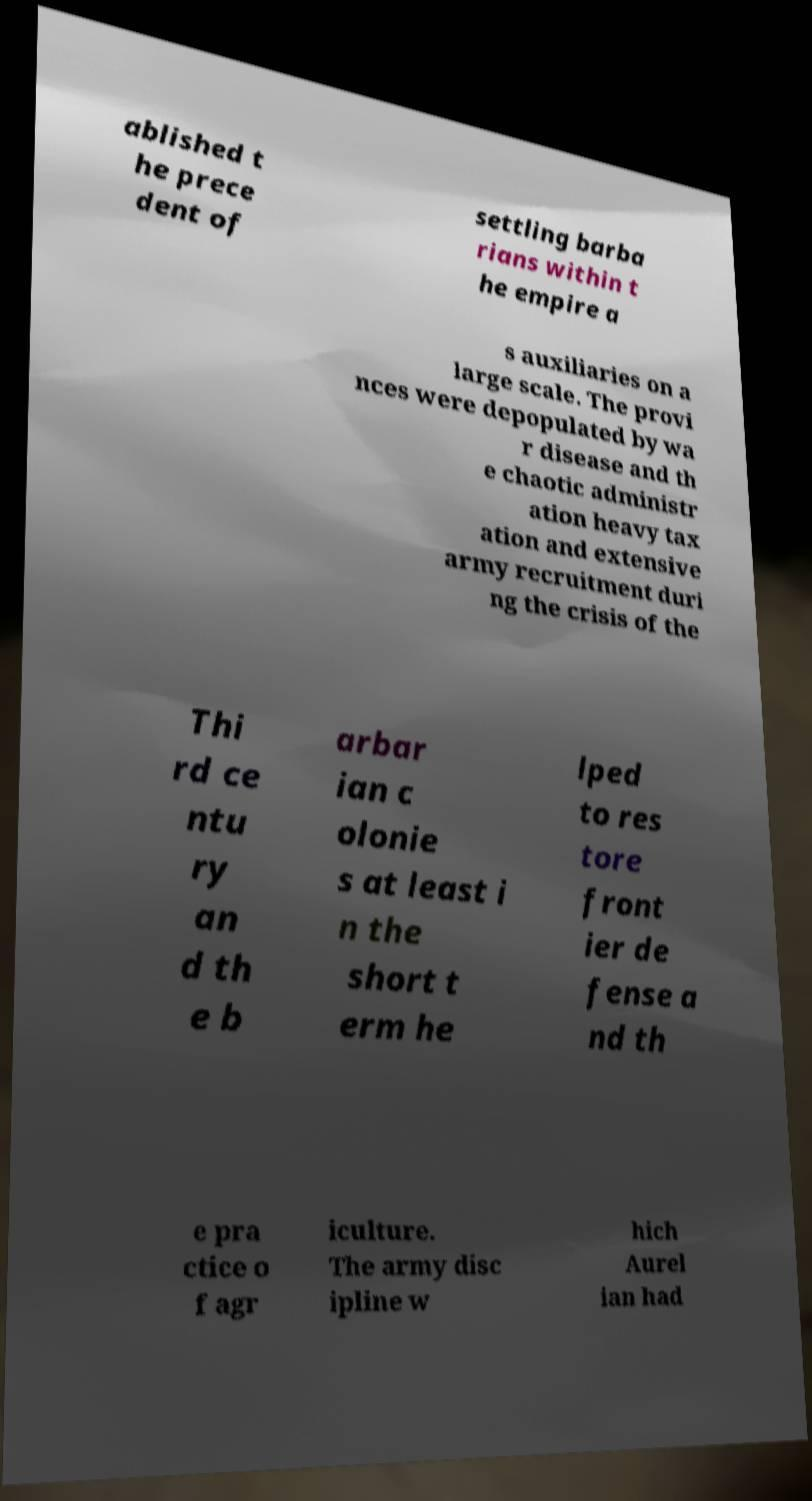For documentation purposes, I need the text within this image transcribed. Could you provide that? ablished t he prece dent of settling barba rians within t he empire a s auxiliaries on a large scale. The provi nces were depopulated by wa r disease and th e chaotic administr ation heavy tax ation and extensive army recruitment duri ng the crisis of the Thi rd ce ntu ry an d th e b arbar ian c olonie s at least i n the short t erm he lped to res tore front ier de fense a nd th e pra ctice o f agr iculture. The army disc ipline w hich Aurel ian had 